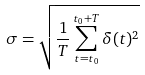<formula> <loc_0><loc_0><loc_500><loc_500>\sigma = \sqrt { \frac { 1 } { T } \sum _ { t = t _ { 0 } } ^ { t _ { 0 } + T } \delta ( t ) ^ { 2 } }</formula> 